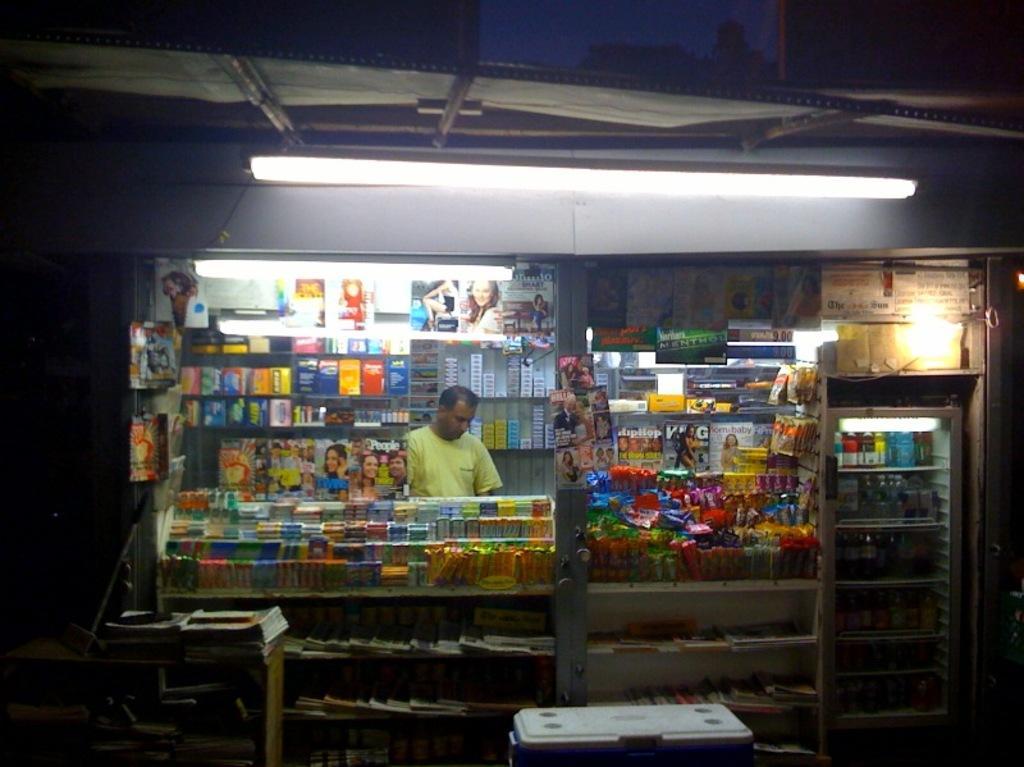In one or two sentences, can you explain what this image depicts? In this image there is a person inside a shop selling various kinds of objects, there is a tube light on the top. 